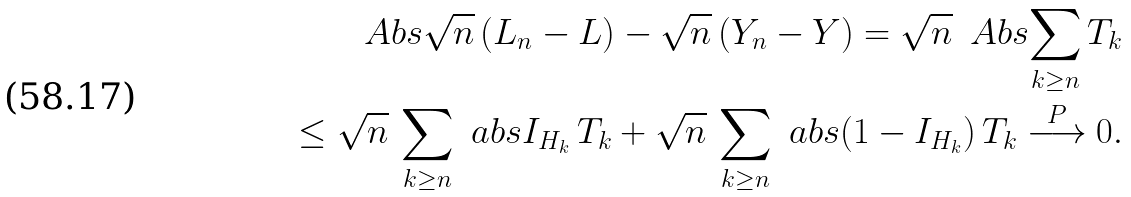<formula> <loc_0><loc_0><loc_500><loc_500>\ A b s { \sqrt { n } \, ( L _ { n } - L ) - \sqrt { n } \, ( Y _ { n } - Y ) } = \sqrt { n } \, \ A b s { \sum _ { k \geq n } T _ { k } } \\ \leq \sqrt { n } \, \sum _ { k \geq n } \ a b s { I _ { H _ { k } } \, T _ { k } } + \sqrt { n } \, \sum _ { k \geq n } \ a b s { ( 1 - I _ { H _ { k } } ) \, T _ { k } } \overset { P } \longrightarrow 0 .</formula> 